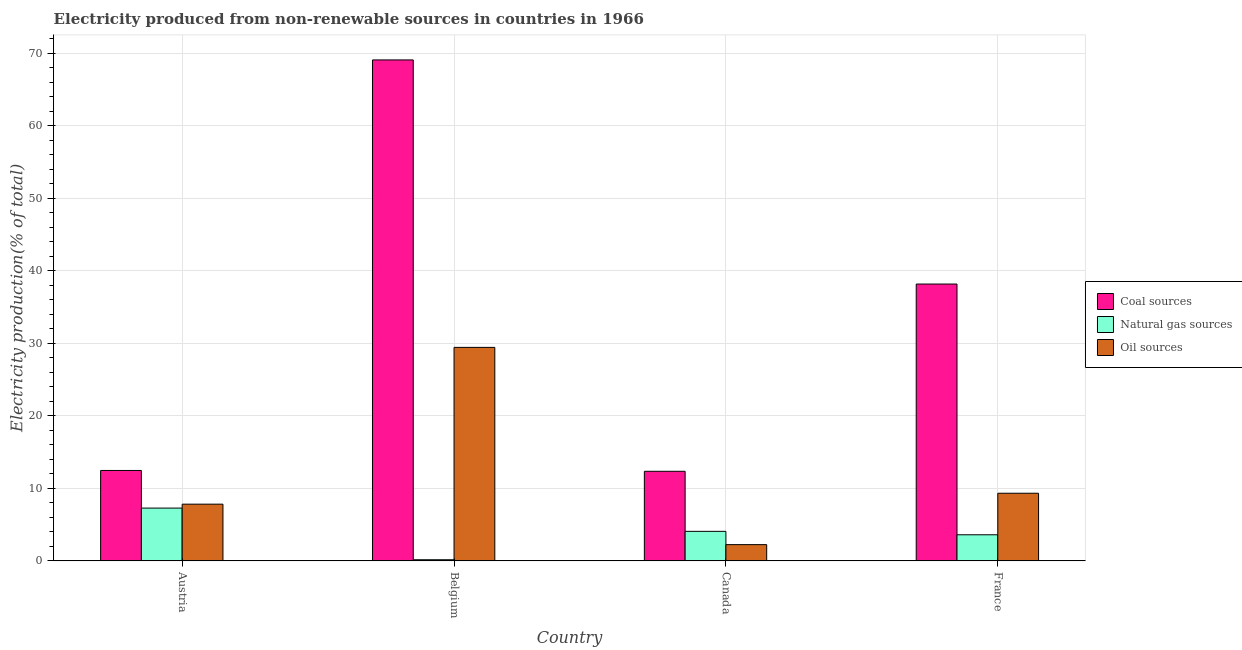How many groups of bars are there?
Offer a terse response. 4. Are the number of bars per tick equal to the number of legend labels?
Keep it short and to the point. Yes. Are the number of bars on each tick of the X-axis equal?
Your answer should be compact. Yes. How many bars are there on the 2nd tick from the left?
Provide a succinct answer. 3. How many bars are there on the 2nd tick from the right?
Keep it short and to the point. 3. In how many cases, is the number of bars for a given country not equal to the number of legend labels?
Your answer should be very brief. 0. What is the percentage of electricity produced by natural gas in Belgium?
Make the answer very short. 0.16. Across all countries, what is the maximum percentage of electricity produced by oil sources?
Give a very brief answer. 29.43. Across all countries, what is the minimum percentage of electricity produced by coal?
Make the answer very short. 12.35. In which country was the percentage of electricity produced by coal maximum?
Offer a terse response. Belgium. In which country was the percentage of electricity produced by oil sources minimum?
Ensure brevity in your answer.  Canada. What is the total percentage of electricity produced by coal in the graph?
Your answer should be compact. 132.05. What is the difference between the percentage of electricity produced by oil sources in Austria and that in France?
Your answer should be very brief. -1.51. What is the difference between the percentage of electricity produced by natural gas in Belgium and the percentage of electricity produced by oil sources in Austria?
Your response must be concise. -7.66. What is the average percentage of electricity produced by coal per country?
Your response must be concise. 33.01. What is the difference between the percentage of electricity produced by oil sources and percentage of electricity produced by natural gas in France?
Offer a very short reply. 5.73. In how many countries, is the percentage of electricity produced by natural gas greater than 30 %?
Your response must be concise. 0. What is the ratio of the percentage of electricity produced by natural gas in Austria to that in Belgium?
Your response must be concise. 45.81. What is the difference between the highest and the second highest percentage of electricity produced by coal?
Your response must be concise. 30.89. What is the difference between the highest and the lowest percentage of electricity produced by natural gas?
Make the answer very short. 7.12. What does the 1st bar from the left in France represents?
Provide a succinct answer. Coal sources. What does the 3rd bar from the right in Belgium represents?
Make the answer very short. Coal sources. Is it the case that in every country, the sum of the percentage of electricity produced by coal and percentage of electricity produced by natural gas is greater than the percentage of electricity produced by oil sources?
Keep it short and to the point. Yes. Are all the bars in the graph horizontal?
Ensure brevity in your answer.  No. Are the values on the major ticks of Y-axis written in scientific E-notation?
Your answer should be compact. No. Does the graph contain any zero values?
Your answer should be very brief. No. Where does the legend appear in the graph?
Ensure brevity in your answer.  Center right. How many legend labels are there?
Offer a very short reply. 3. What is the title of the graph?
Your answer should be very brief. Electricity produced from non-renewable sources in countries in 1966. What is the Electricity production(% of total) in Coal sources in Austria?
Your answer should be very brief. 12.47. What is the Electricity production(% of total) of Natural gas sources in Austria?
Offer a terse response. 7.28. What is the Electricity production(% of total) in Oil sources in Austria?
Your answer should be very brief. 7.82. What is the Electricity production(% of total) in Coal sources in Belgium?
Ensure brevity in your answer.  69.06. What is the Electricity production(% of total) in Natural gas sources in Belgium?
Offer a very short reply. 0.16. What is the Electricity production(% of total) in Oil sources in Belgium?
Keep it short and to the point. 29.43. What is the Electricity production(% of total) in Coal sources in Canada?
Ensure brevity in your answer.  12.35. What is the Electricity production(% of total) of Natural gas sources in Canada?
Make the answer very short. 4.07. What is the Electricity production(% of total) of Oil sources in Canada?
Provide a succinct answer. 2.24. What is the Electricity production(% of total) of Coal sources in France?
Provide a short and direct response. 38.17. What is the Electricity production(% of total) in Natural gas sources in France?
Offer a very short reply. 3.6. What is the Electricity production(% of total) in Oil sources in France?
Offer a very short reply. 9.33. Across all countries, what is the maximum Electricity production(% of total) in Coal sources?
Provide a succinct answer. 69.06. Across all countries, what is the maximum Electricity production(% of total) of Natural gas sources?
Provide a short and direct response. 7.28. Across all countries, what is the maximum Electricity production(% of total) of Oil sources?
Offer a very short reply. 29.43. Across all countries, what is the minimum Electricity production(% of total) in Coal sources?
Your answer should be very brief. 12.35. Across all countries, what is the minimum Electricity production(% of total) of Natural gas sources?
Your answer should be very brief. 0.16. Across all countries, what is the minimum Electricity production(% of total) in Oil sources?
Keep it short and to the point. 2.24. What is the total Electricity production(% of total) in Coal sources in the graph?
Give a very brief answer. 132.05. What is the total Electricity production(% of total) of Natural gas sources in the graph?
Offer a terse response. 15.11. What is the total Electricity production(% of total) in Oil sources in the graph?
Ensure brevity in your answer.  48.82. What is the difference between the Electricity production(% of total) of Coal sources in Austria and that in Belgium?
Provide a short and direct response. -56.59. What is the difference between the Electricity production(% of total) in Natural gas sources in Austria and that in Belgium?
Ensure brevity in your answer.  7.12. What is the difference between the Electricity production(% of total) in Oil sources in Austria and that in Belgium?
Your answer should be compact. -21.61. What is the difference between the Electricity production(% of total) in Coal sources in Austria and that in Canada?
Make the answer very short. 0.11. What is the difference between the Electricity production(% of total) of Natural gas sources in Austria and that in Canada?
Your answer should be compact. 3.21. What is the difference between the Electricity production(% of total) of Oil sources in Austria and that in Canada?
Provide a short and direct response. 5.58. What is the difference between the Electricity production(% of total) in Coal sources in Austria and that in France?
Ensure brevity in your answer.  -25.7. What is the difference between the Electricity production(% of total) of Natural gas sources in Austria and that in France?
Your response must be concise. 3.68. What is the difference between the Electricity production(% of total) of Oil sources in Austria and that in France?
Offer a terse response. -1.51. What is the difference between the Electricity production(% of total) of Coal sources in Belgium and that in Canada?
Keep it short and to the point. 56.71. What is the difference between the Electricity production(% of total) of Natural gas sources in Belgium and that in Canada?
Make the answer very short. -3.91. What is the difference between the Electricity production(% of total) of Oil sources in Belgium and that in Canada?
Provide a short and direct response. 27.19. What is the difference between the Electricity production(% of total) of Coal sources in Belgium and that in France?
Your answer should be very brief. 30.89. What is the difference between the Electricity production(% of total) of Natural gas sources in Belgium and that in France?
Provide a succinct answer. -3.44. What is the difference between the Electricity production(% of total) of Oil sources in Belgium and that in France?
Your answer should be compact. 20.11. What is the difference between the Electricity production(% of total) in Coal sources in Canada and that in France?
Make the answer very short. -25.81. What is the difference between the Electricity production(% of total) in Natural gas sources in Canada and that in France?
Offer a terse response. 0.47. What is the difference between the Electricity production(% of total) of Oil sources in Canada and that in France?
Provide a short and direct response. -7.08. What is the difference between the Electricity production(% of total) in Coal sources in Austria and the Electricity production(% of total) in Natural gas sources in Belgium?
Provide a succinct answer. 12.31. What is the difference between the Electricity production(% of total) in Coal sources in Austria and the Electricity production(% of total) in Oil sources in Belgium?
Give a very brief answer. -16.97. What is the difference between the Electricity production(% of total) in Natural gas sources in Austria and the Electricity production(% of total) in Oil sources in Belgium?
Ensure brevity in your answer.  -22.15. What is the difference between the Electricity production(% of total) of Coal sources in Austria and the Electricity production(% of total) of Natural gas sources in Canada?
Your answer should be very brief. 8.39. What is the difference between the Electricity production(% of total) of Coal sources in Austria and the Electricity production(% of total) of Oil sources in Canada?
Ensure brevity in your answer.  10.22. What is the difference between the Electricity production(% of total) in Natural gas sources in Austria and the Electricity production(% of total) in Oil sources in Canada?
Provide a succinct answer. 5.04. What is the difference between the Electricity production(% of total) of Coal sources in Austria and the Electricity production(% of total) of Natural gas sources in France?
Keep it short and to the point. 8.87. What is the difference between the Electricity production(% of total) of Coal sources in Austria and the Electricity production(% of total) of Oil sources in France?
Keep it short and to the point. 3.14. What is the difference between the Electricity production(% of total) in Natural gas sources in Austria and the Electricity production(% of total) in Oil sources in France?
Your response must be concise. -2.05. What is the difference between the Electricity production(% of total) of Coal sources in Belgium and the Electricity production(% of total) of Natural gas sources in Canada?
Offer a terse response. 64.99. What is the difference between the Electricity production(% of total) of Coal sources in Belgium and the Electricity production(% of total) of Oil sources in Canada?
Ensure brevity in your answer.  66.82. What is the difference between the Electricity production(% of total) of Natural gas sources in Belgium and the Electricity production(% of total) of Oil sources in Canada?
Provide a short and direct response. -2.08. What is the difference between the Electricity production(% of total) of Coal sources in Belgium and the Electricity production(% of total) of Natural gas sources in France?
Ensure brevity in your answer.  65.46. What is the difference between the Electricity production(% of total) of Coal sources in Belgium and the Electricity production(% of total) of Oil sources in France?
Your response must be concise. 59.73. What is the difference between the Electricity production(% of total) of Natural gas sources in Belgium and the Electricity production(% of total) of Oil sources in France?
Ensure brevity in your answer.  -9.17. What is the difference between the Electricity production(% of total) in Coal sources in Canada and the Electricity production(% of total) in Natural gas sources in France?
Offer a terse response. 8.75. What is the difference between the Electricity production(% of total) of Coal sources in Canada and the Electricity production(% of total) of Oil sources in France?
Provide a short and direct response. 3.03. What is the difference between the Electricity production(% of total) of Natural gas sources in Canada and the Electricity production(% of total) of Oil sources in France?
Your answer should be compact. -5.25. What is the average Electricity production(% of total) in Coal sources per country?
Give a very brief answer. 33.01. What is the average Electricity production(% of total) of Natural gas sources per country?
Your answer should be very brief. 3.78. What is the average Electricity production(% of total) in Oil sources per country?
Offer a very short reply. 12.21. What is the difference between the Electricity production(% of total) in Coal sources and Electricity production(% of total) in Natural gas sources in Austria?
Offer a very short reply. 5.19. What is the difference between the Electricity production(% of total) of Coal sources and Electricity production(% of total) of Oil sources in Austria?
Offer a very short reply. 4.65. What is the difference between the Electricity production(% of total) of Natural gas sources and Electricity production(% of total) of Oil sources in Austria?
Offer a very short reply. -0.54. What is the difference between the Electricity production(% of total) in Coal sources and Electricity production(% of total) in Natural gas sources in Belgium?
Make the answer very short. 68.9. What is the difference between the Electricity production(% of total) of Coal sources and Electricity production(% of total) of Oil sources in Belgium?
Keep it short and to the point. 39.63. What is the difference between the Electricity production(% of total) in Natural gas sources and Electricity production(% of total) in Oil sources in Belgium?
Ensure brevity in your answer.  -29.27. What is the difference between the Electricity production(% of total) of Coal sources and Electricity production(% of total) of Natural gas sources in Canada?
Your answer should be very brief. 8.28. What is the difference between the Electricity production(% of total) of Coal sources and Electricity production(% of total) of Oil sources in Canada?
Provide a succinct answer. 10.11. What is the difference between the Electricity production(% of total) of Natural gas sources and Electricity production(% of total) of Oil sources in Canada?
Offer a terse response. 1.83. What is the difference between the Electricity production(% of total) of Coal sources and Electricity production(% of total) of Natural gas sources in France?
Your response must be concise. 34.57. What is the difference between the Electricity production(% of total) in Coal sources and Electricity production(% of total) in Oil sources in France?
Ensure brevity in your answer.  28.84. What is the difference between the Electricity production(% of total) of Natural gas sources and Electricity production(% of total) of Oil sources in France?
Your answer should be very brief. -5.73. What is the ratio of the Electricity production(% of total) in Coal sources in Austria to that in Belgium?
Keep it short and to the point. 0.18. What is the ratio of the Electricity production(% of total) of Natural gas sources in Austria to that in Belgium?
Offer a very short reply. 45.81. What is the ratio of the Electricity production(% of total) of Oil sources in Austria to that in Belgium?
Ensure brevity in your answer.  0.27. What is the ratio of the Electricity production(% of total) of Coal sources in Austria to that in Canada?
Keep it short and to the point. 1.01. What is the ratio of the Electricity production(% of total) of Natural gas sources in Austria to that in Canada?
Give a very brief answer. 1.79. What is the ratio of the Electricity production(% of total) in Oil sources in Austria to that in Canada?
Give a very brief answer. 3.49. What is the ratio of the Electricity production(% of total) in Coal sources in Austria to that in France?
Provide a short and direct response. 0.33. What is the ratio of the Electricity production(% of total) of Natural gas sources in Austria to that in France?
Your answer should be compact. 2.02. What is the ratio of the Electricity production(% of total) of Oil sources in Austria to that in France?
Ensure brevity in your answer.  0.84. What is the ratio of the Electricity production(% of total) in Coal sources in Belgium to that in Canada?
Your response must be concise. 5.59. What is the ratio of the Electricity production(% of total) in Natural gas sources in Belgium to that in Canada?
Your answer should be compact. 0.04. What is the ratio of the Electricity production(% of total) of Oil sources in Belgium to that in Canada?
Provide a succinct answer. 13.12. What is the ratio of the Electricity production(% of total) of Coal sources in Belgium to that in France?
Give a very brief answer. 1.81. What is the ratio of the Electricity production(% of total) of Natural gas sources in Belgium to that in France?
Offer a terse response. 0.04. What is the ratio of the Electricity production(% of total) in Oil sources in Belgium to that in France?
Make the answer very short. 3.16. What is the ratio of the Electricity production(% of total) in Coal sources in Canada to that in France?
Your answer should be compact. 0.32. What is the ratio of the Electricity production(% of total) in Natural gas sources in Canada to that in France?
Offer a terse response. 1.13. What is the ratio of the Electricity production(% of total) of Oil sources in Canada to that in France?
Ensure brevity in your answer.  0.24. What is the difference between the highest and the second highest Electricity production(% of total) of Coal sources?
Offer a very short reply. 30.89. What is the difference between the highest and the second highest Electricity production(% of total) in Natural gas sources?
Your answer should be very brief. 3.21. What is the difference between the highest and the second highest Electricity production(% of total) in Oil sources?
Provide a succinct answer. 20.11. What is the difference between the highest and the lowest Electricity production(% of total) in Coal sources?
Your response must be concise. 56.71. What is the difference between the highest and the lowest Electricity production(% of total) of Natural gas sources?
Offer a very short reply. 7.12. What is the difference between the highest and the lowest Electricity production(% of total) of Oil sources?
Offer a terse response. 27.19. 